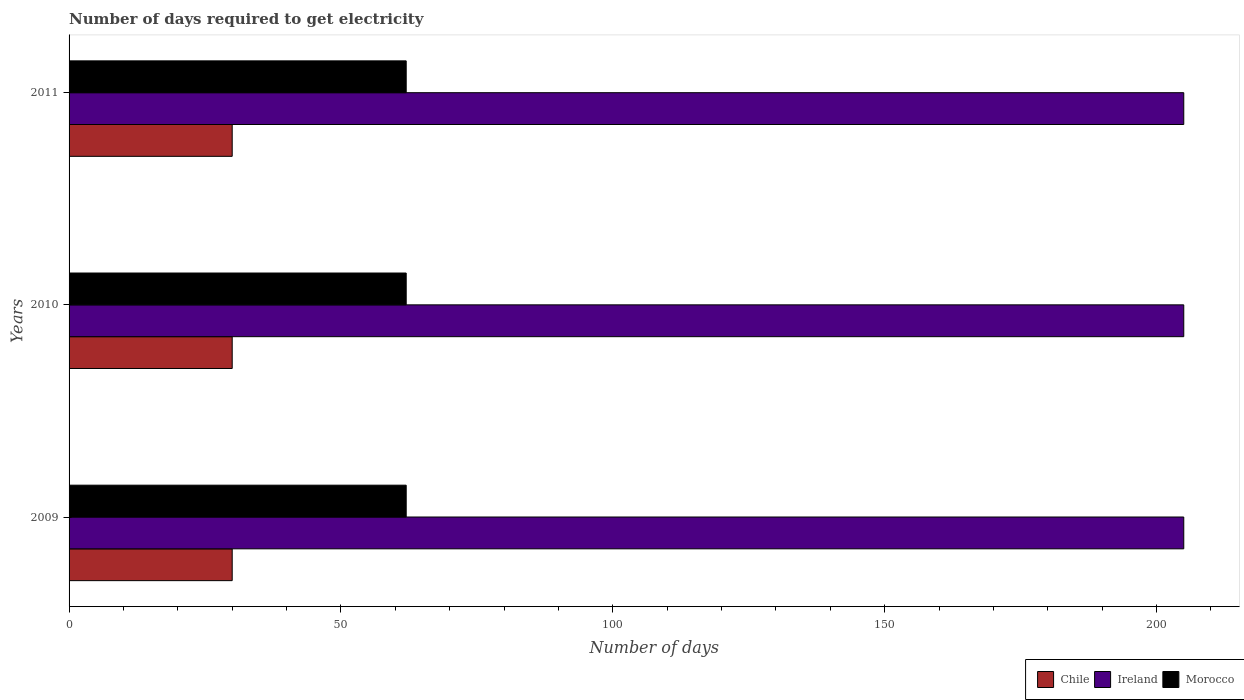How many groups of bars are there?
Your response must be concise. 3. Are the number of bars per tick equal to the number of legend labels?
Your answer should be very brief. Yes. Are the number of bars on each tick of the Y-axis equal?
Offer a very short reply. Yes. How many bars are there on the 1st tick from the top?
Provide a succinct answer. 3. How many bars are there on the 1st tick from the bottom?
Provide a succinct answer. 3. What is the label of the 2nd group of bars from the top?
Offer a very short reply. 2010. What is the number of days required to get electricity in in Ireland in 2011?
Keep it short and to the point. 205. Across all years, what is the maximum number of days required to get electricity in in Chile?
Provide a succinct answer. 30. Across all years, what is the minimum number of days required to get electricity in in Morocco?
Your answer should be compact. 62. In which year was the number of days required to get electricity in in Chile maximum?
Keep it short and to the point. 2009. What is the total number of days required to get electricity in in Chile in the graph?
Offer a terse response. 90. What is the difference between the number of days required to get electricity in in Ireland in 2010 and the number of days required to get electricity in in Morocco in 2009?
Give a very brief answer. 143. What is the average number of days required to get electricity in in Ireland per year?
Provide a succinct answer. 205. In the year 2009, what is the difference between the number of days required to get electricity in in Ireland and number of days required to get electricity in in Morocco?
Give a very brief answer. 143. In how many years, is the number of days required to get electricity in in Ireland greater than 160 days?
Provide a short and direct response. 3. What is the difference between the highest and the lowest number of days required to get electricity in in Morocco?
Provide a succinct answer. 0. Is the sum of the number of days required to get electricity in in Morocco in 2009 and 2011 greater than the maximum number of days required to get electricity in in Ireland across all years?
Offer a terse response. No. What does the 2nd bar from the bottom in 2011 represents?
Make the answer very short. Ireland. Are all the bars in the graph horizontal?
Your response must be concise. Yes. How many years are there in the graph?
Make the answer very short. 3. Are the values on the major ticks of X-axis written in scientific E-notation?
Ensure brevity in your answer.  No. Does the graph contain any zero values?
Provide a succinct answer. No. Does the graph contain grids?
Ensure brevity in your answer.  No. How many legend labels are there?
Offer a terse response. 3. What is the title of the graph?
Make the answer very short. Number of days required to get electricity. Does "Germany" appear as one of the legend labels in the graph?
Provide a short and direct response. No. What is the label or title of the X-axis?
Provide a succinct answer. Number of days. What is the label or title of the Y-axis?
Offer a very short reply. Years. What is the Number of days of Chile in 2009?
Give a very brief answer. 30. What is the Number of days of Ireland in 2009?
Make the answer very short. 205. What is the Number of days of Chile in 2010?
Keep it short and to the point. 30. What is the Number of days in Ireland in 2010?
Your answer should be very brief. 205. What is the Number of days of Ireland in 2011?
Ensure brevity in your answer.  205. What is the Number of days in Morocco in 2011?
Your answer should be compact. 62. Across all years, what is the maximum Number of days in Ireland?
Offer a terse response. 205. Across all years, what is the minimum Number of days of Ireland?
Provide a succinct answer. 205. What is the total Number of days of Chile in the graph?
Give a very brief answer. 90. What is the total Number of days in Ireland in the graph?
Provide a succinct answer. 615. What is the total Number of days in Morocco in the graph?
Offer a terse response. 186. What is the difference between the Number of days of Ireland in 2009 and that in 2010?
Your answer should be very brief. 0. What is the difference between the Number of days in Chile in 2010 and that in 2011?
Your answer should be compact. 0. What is the difference between the Number of days of Ireland in 2010 and that in 2011?
Your answer should be very brief. 0. What is the difference between the Number of days in Chile in 2009 and the Number of days in Ireland in 2010?
Give a very brief answer. -175. What is the difference between the Number of days in Chile in 2009 and the Number of days in Morocco in 2010?
Keep it short and to the point. -32. What is the difference between the Number of days in Ireland in 2009 and the Number of days in Morocco in 2010?
Provide a succinct answer. 143. What is the difference between the Number of days in Chile in 2009 and the Number of days in Ireland in 2011?
Provide a succinct answer. -175. What is the difference between the Number of days in Chile in 2009 and the Number of days in Morocco in 2011?
Provide a short and direct response. -32. What is the difference between the Number of days of Ireland in 2009 and the Number of days of Morocco in 2011?
Provide a succinct answer. 143. What is the difference between the Number of days in Chile in 2010 and the Number of days in Ireland in 2011?
Make the answer very short. -175. What is the difference between the Number of days in Chile in 2010 and the Number of days in Morocco in 2011?
Provide a short and direct response. -32. What is the difference between the Number of days of Ireland in 2010 and the Number of days of Morocco in 2011?
Provide a short and direct response. 143. What is the average Number of days of Ireland per year?
Your answer should be very brief. 205. In the year 2009, what is the difference between the Number of days in Chile and Number of days in Ireland?
Offer a very short reply. -175. In the year 2009, what is the difference between the Number of days in Chile and Number of days in Morocco?
Provide a succinct answer. -32. In the year 2009, what is the difference between the Number of days of Ireland and Number of days of Morocco?
Keep it short and to the point. 143. In the year 2010, what is the difference between the Number of days in Chile and Number of days in Ireland?
Offer a terse response. -175. In the year 2010, what is the difference between the Number of days in Chile and Number of days in Morocco?
Give a very brief answer. -32. In the year 2010, what is the difference between the Number of days in Ireland and Number of days in Morocco?
Provide a short and direct response. 143. In the year 2011, what is the difference between the Number of days in Chile and Number of days in Ireland?
Provide a succinct answer. -175. In the year 2011, what is the difference between the Number of days of Chile and Number of days of Morocco?
Your answer should be compact. -32. In the year 2011, what is the difference between the Number of days of Ireland and Number of days of Morocco?
Offer a terse response. 143. What is the ratio of the Number of days in Chile in 2009 to that in 2010?
Ensure brevity in your answer.  1. What is the ratio of the Number of days in Morocco in 2009 to that in 2011?
Your response must be concise. 1. What is the ratio of the Number of days of Morocco in 2010 to that in 2011?
Your response must be concise. 1. What is the difference between the highest and the second highest Number of days of Chile?
Provide a short and direct response. 0. What is the difference between the highest and the lowest Number of days in Chile?
Provide a succinct answer. 0. What is the difference between the highest and the lowest Number of days in Ireland?
Offer a very short reply. 0. What is the difference between the highest and the lowest Number of days in Morocco?
Give a very brief answer. 0. 